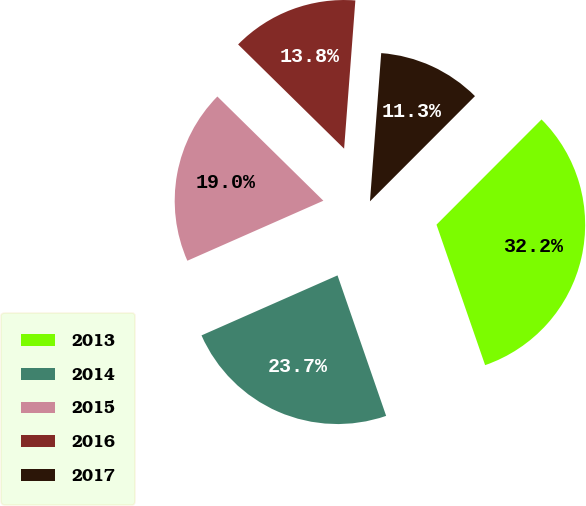Convert chart. <chart><loc_0><loc_0><loc_500><loc_500><pie_chart><fcel>2013<fcel>2014<fcel>2015<fcel>2016<fcel>2017<nl><fcel>32.21%<fcel>23.69%<fcel>18.98%<fcel>13.84%<fcel>11.28%<nl></chart> 